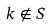<formula> <loc_0><loc_0><loc_500><loc_500>k \notin S</formula> 